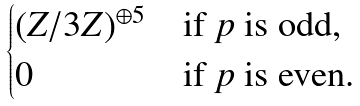Convert formula to latex. <formula><loc_0><loc_0><loc_500><loc_500>\begin{cases} ( Z / 3 Z ) ^ { \oplus 5 } & \text {if $p$ is odd,} \\ 0 & \text {if $p$ is even.} \end{cases}</formula> 